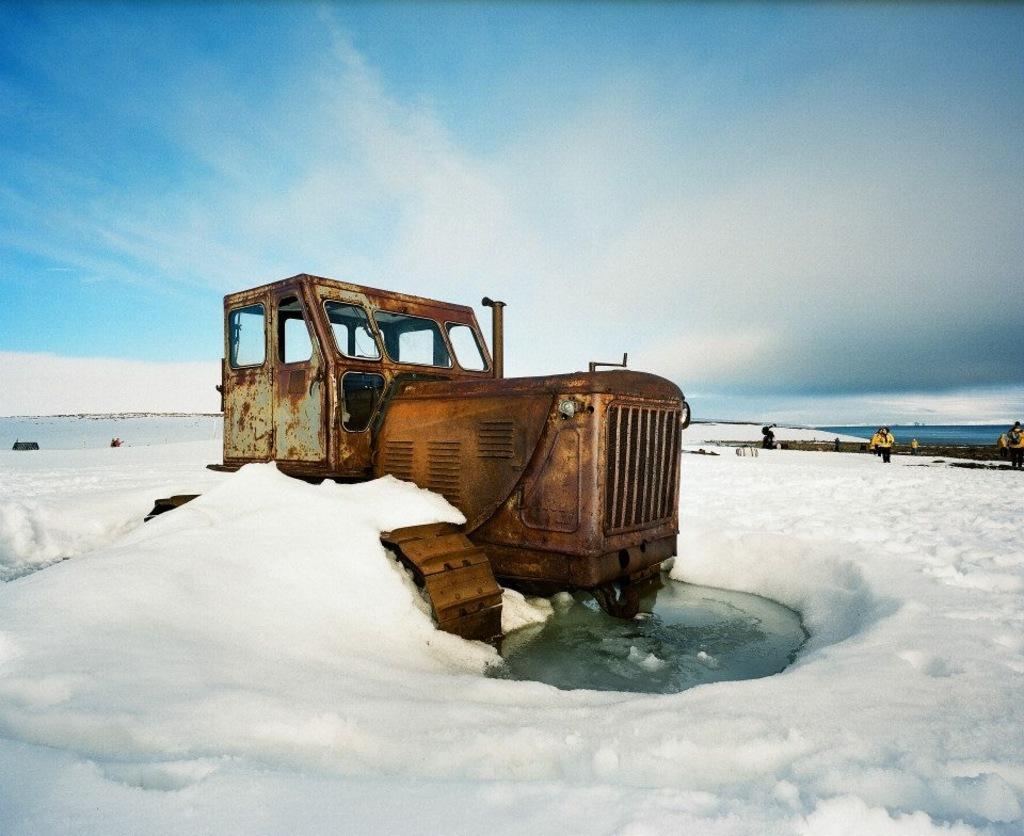Please provide a concise description of this image. This picture is clicked outside. In the center we can see a vehicle and we can see there is a lot of snow. In the background we can see the sky, group of persons and some other objects. 